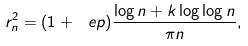Convert formula to latex. <formula><loc_0><loc_0><loc_500><loc_500>r _ { n } ^ { 2 } = ( 1 + \ e p ) \frac { \log n + k \log \log n } { \pi n } ,</formula> 